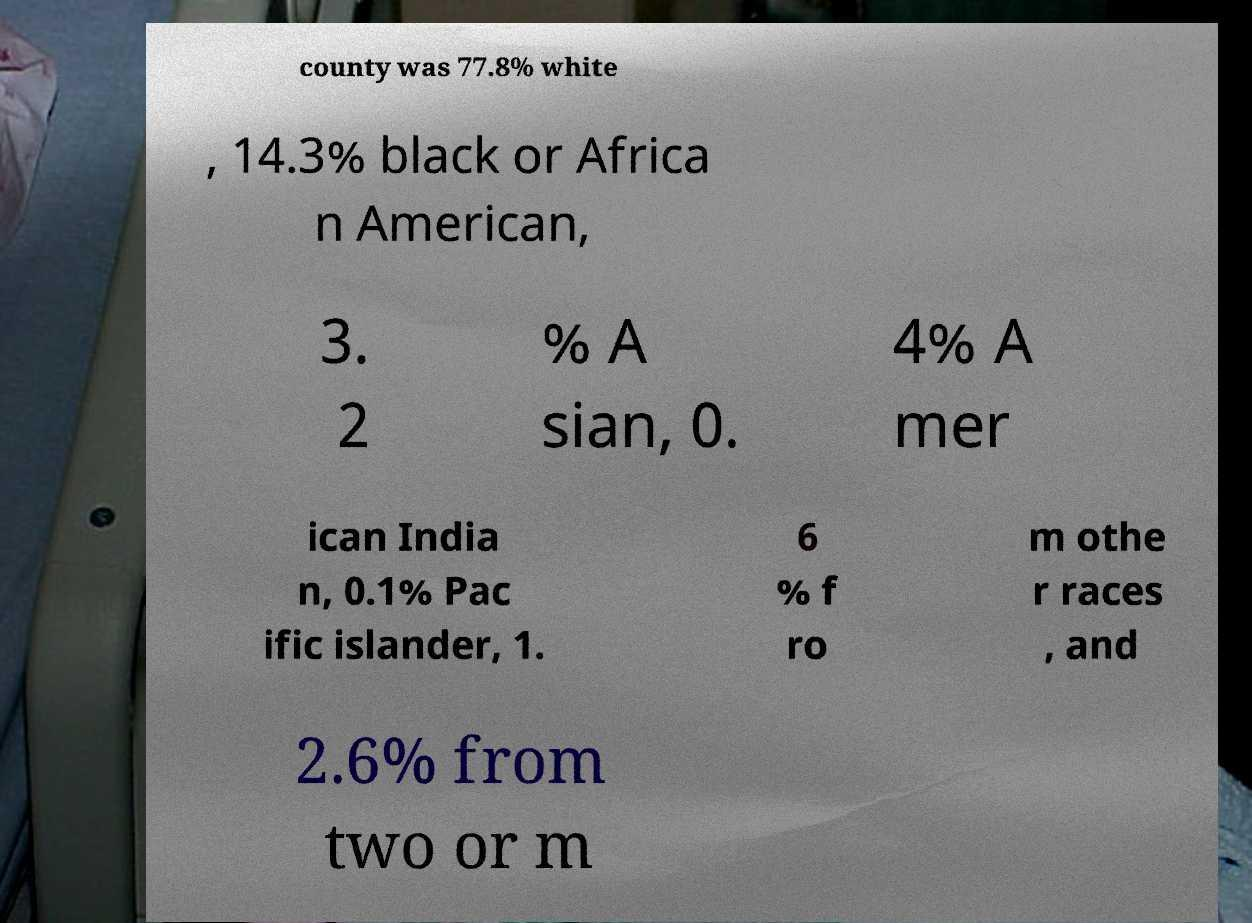Could you assist in decoding the text presented in this image and type it out clearly? county was 77.8% white , 14.3% black or Africa n American, 3. 2 % A sian, 0. 4% A mer ican India n, 0.1% Pac ific islander, 1. 6 % f ro m othe r races , and 2.6% from two or m 